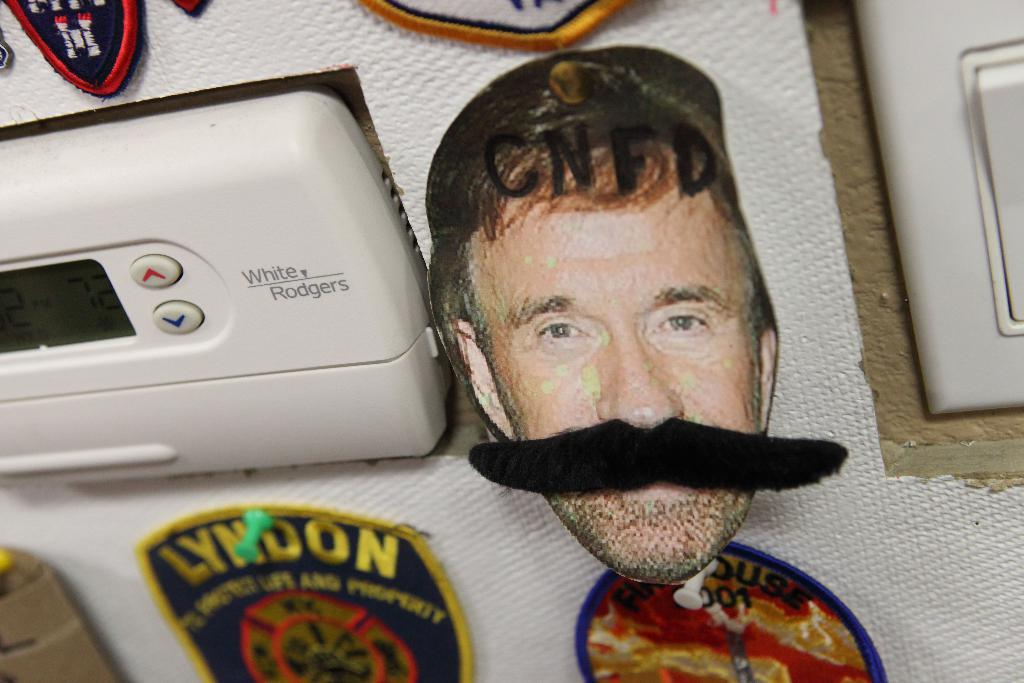<image>
Give a short and clear explanation of the subsequent image. a picture of a man with a black mustache next to a patch that says 'lyndon' on it 